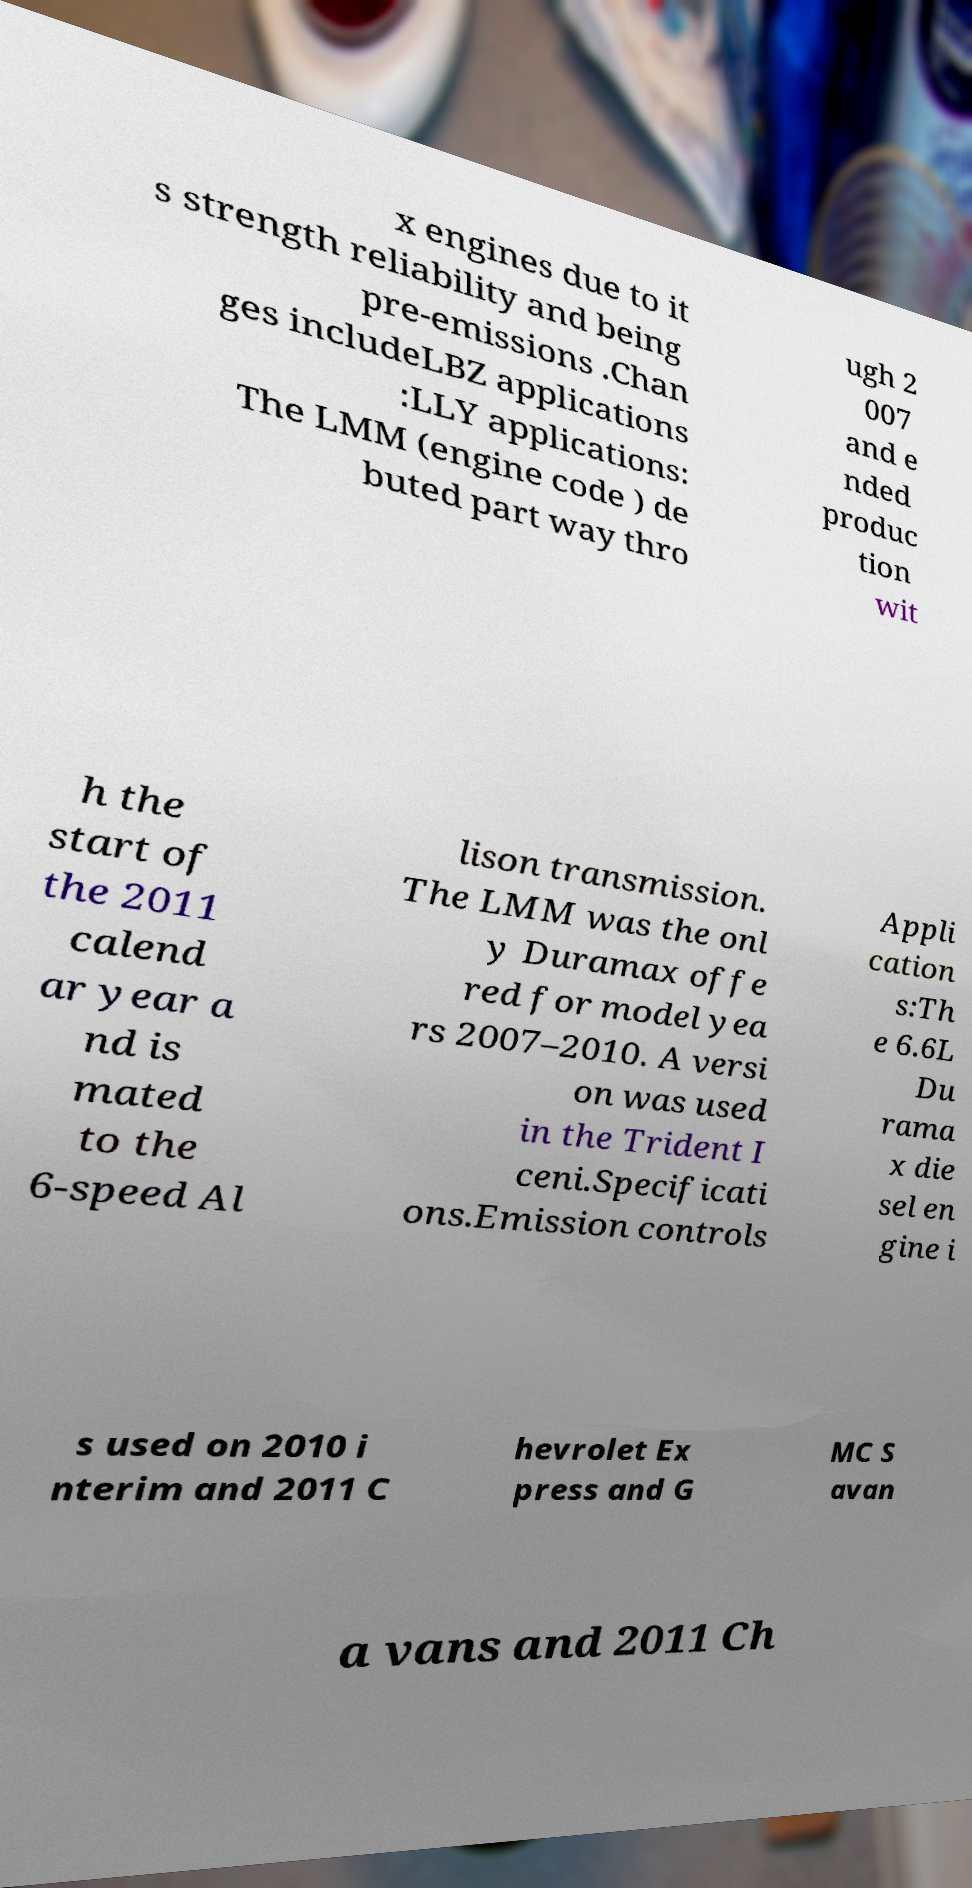Could you extract and type out the text from this image? x engines due to it s strength reliability and being pre-emissions .Chan ges includeLBZ applications :LLY applications: The LMM (engine code ) de buted part way thro ugh 2 007 and e nded produc tion wit h the start of the 2011 calend ar year a nd is mated to the 6-speed Al lison transmission. The LMM was the onl y Duramax offe red for model yea rs 2007–2010. A versi on was used in the Trident I ceni.Specificati ons.Emission controls Appli cation s:Th e 6.6L Du rama x die sel en gine i s used on 2010 i nterim and 2011 C hevrolet Ex press and G MC S avan a vans and 2011 Ch 